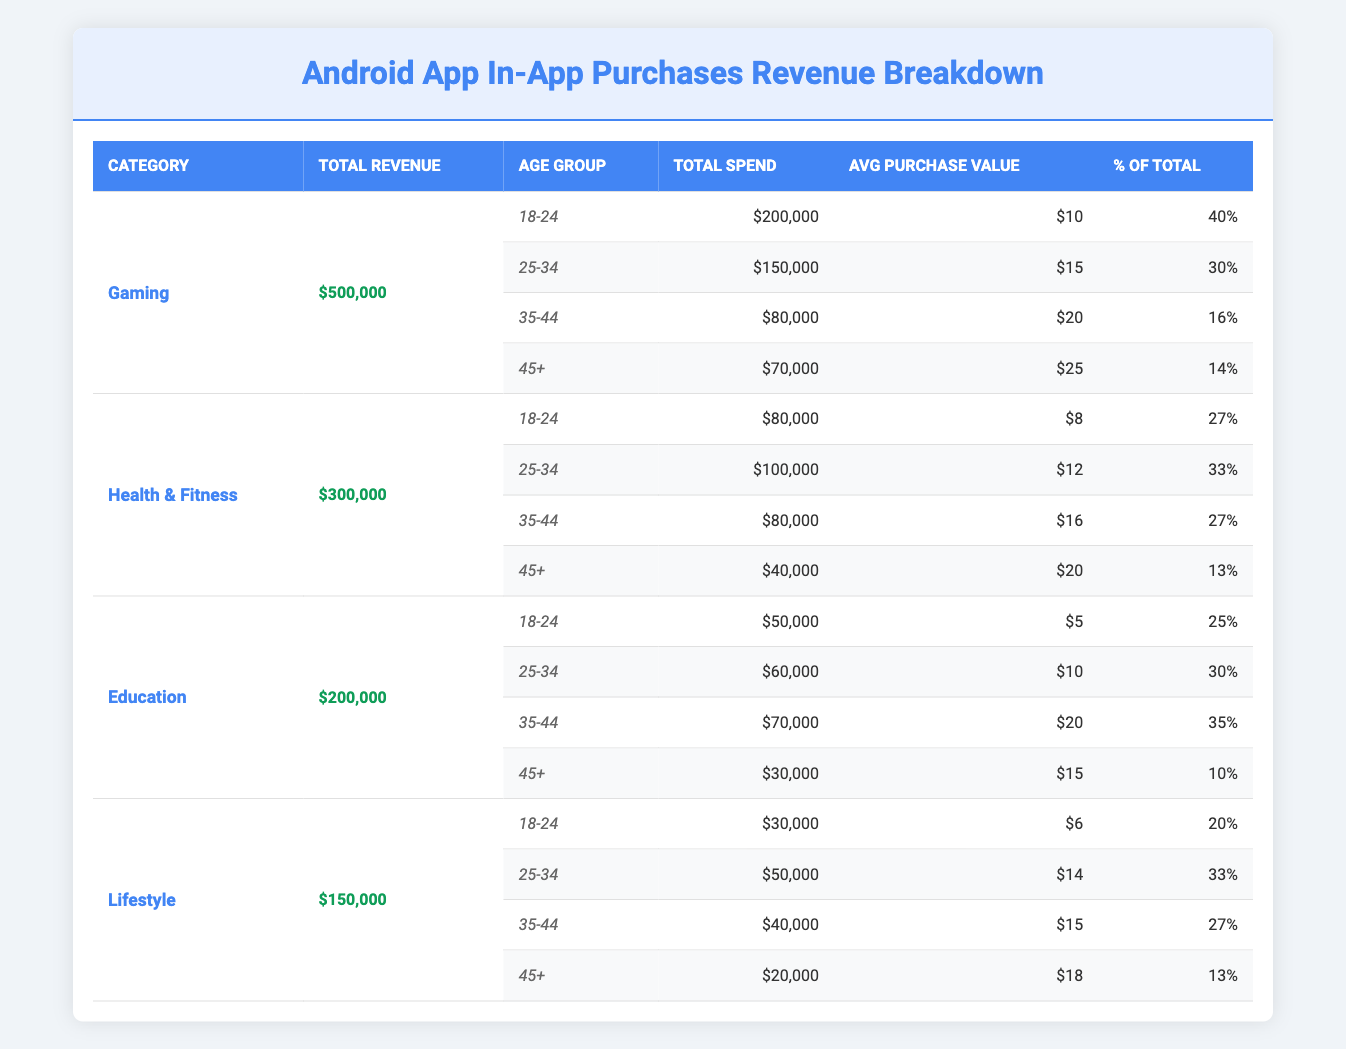What is the total revenue from the Gaming category? The table shows that the total revenue from the Gaming category is listed directly under the "Total Revenue" column for that category, which states $500,000.
Answer: $500,000 Which age group spent the most in the Health & Fitness category? In the Health & Fitness category, the age group with the highest “Total Spend” is 25-34, who spent $100,000, which is more than the other age groups listed.
Answer: 25-34 What is the average purchase value for the Education category? To find the average purchase value for the Education category, we need to look at the "Avg Purchase Value" for the four age groups within that category: (5 + 10 + 20 + 15) / 4 = 12.5.
Answer: 12.5 Is the percentage of total spend for the 18-24 age group in the Gaming category higher than in the Health & Fitness category? For the Gaming category, the percentage for 18-24 is 40%, while for Health & Fitness, it is 27%. Since 40% is greater than 27%, the statement is true.
Answer: Yes What is the combined total spend of the 35-44 age group across all categories? To find the combined total spend of the 35-44 age group, we add the total spends from each category for that age group: Gaming ($80,000) + Health & Fitness ($80,000) + Education ($70,000) + Lifestyle ($40,000) = $270,000.
Answer: $270,000 Which category has the highest total revenue from users aged 45 and above? By comparing the total revenues of the various categories specifically for the age group 45+, we find that the Gaming category has $70,000, Health & Fitness has $40,000, Education has $30,000, and Lifestyle has $20,000. The highest is Gaming with $70,000.
Answer: Gaming What is the total revenue for the Lifestyle category compared to the Education category? The total revenue for the Lifestyle category is $150,000, while for the Education category, it is $200,000. Therefore, Education has a higher total revenue than Lifestyle by $50,000.
Answer: Education is higher by $50,000 Which age group has the lowest percentage of total spend across all categories? Checking the "Percentage Of Total" for each age group in all categories, the age group 45+ in the Education category has the lowest percentage at 10%.
Answer: 45+ (Education) What is the total revenue across all categories? The total revenue across all categories is calculated by adding the total revenues: Gaming ($500,000) + Health & Fitness ($300,000) + Education ($200,000) + Lifestyle ($150,000) = $1,150,000.
Answer: $1,150,000 